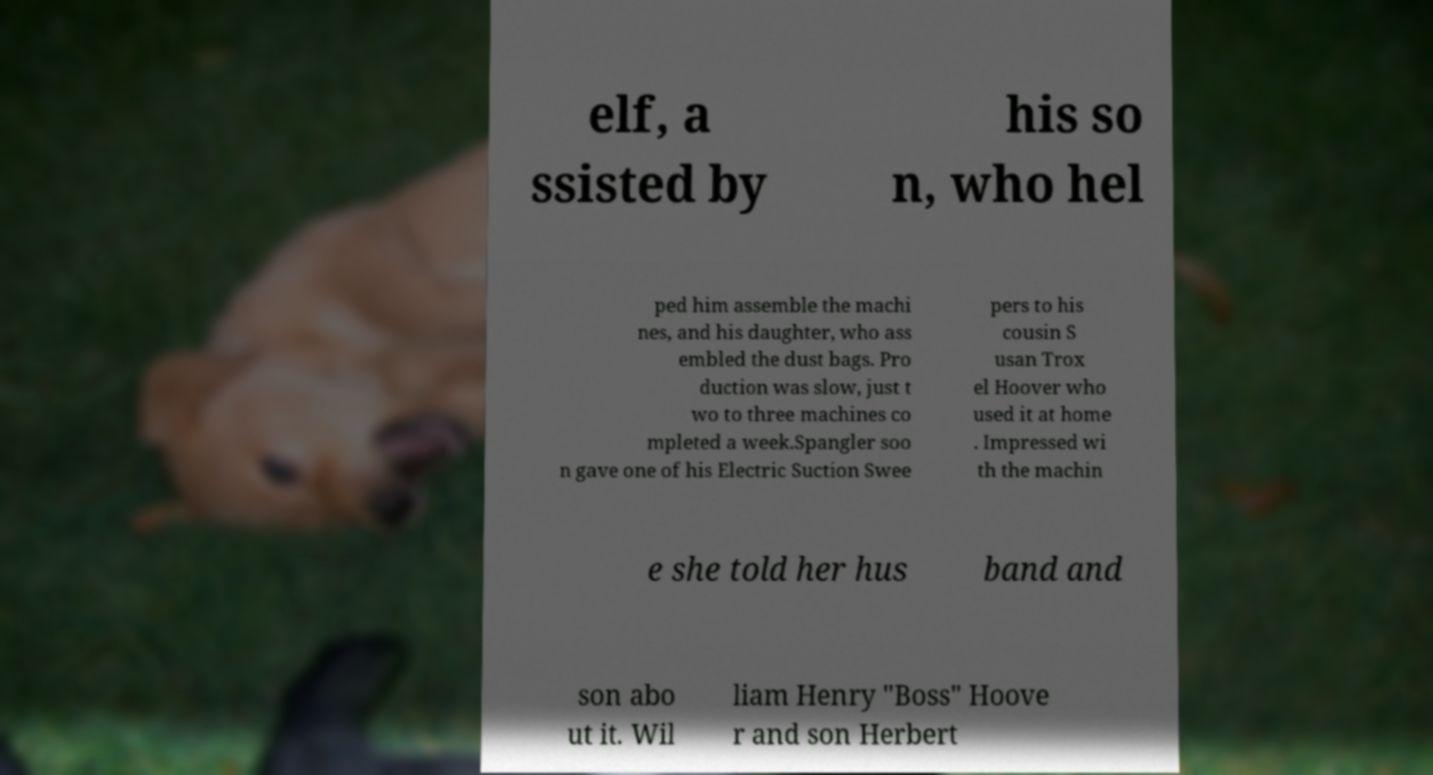Please read and relay the text visible in this image. What does it say? elf, a ssisted by his so n, who hel ped him assemble the machi nes, and his daughter, who ass embled the dust bags. Pro duction was slow, just t wo to three machines co mpleted a week.Spangler soo n gave one of his Electric Suction Swee pers to his cousin S usan Trox el Hoover who used it at home . Impressed wi th the machin e she told her hus band and son abo ut it. Wil liam Henry "Boss" Hoove r and son Herbert 